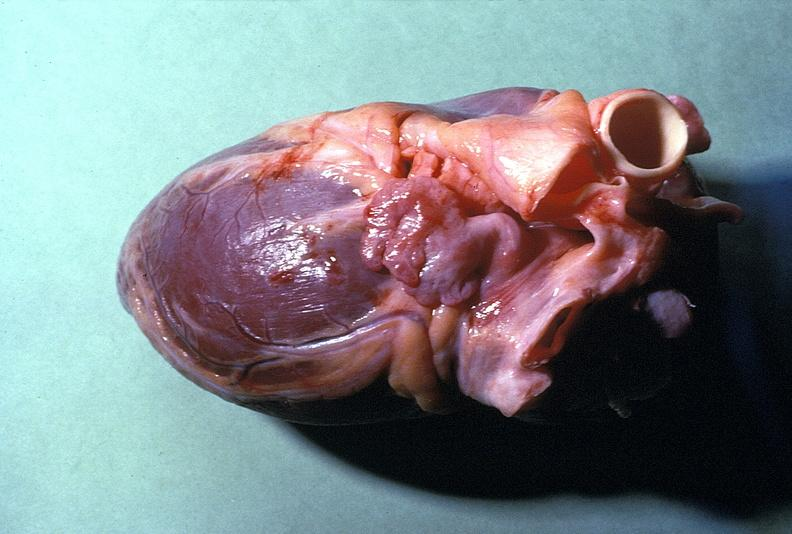does this image shows of smooth muscle cell with lipid in sarcoplasm and lipid show normal cardiovascular?
Answer the question using a single word or phrase. No 